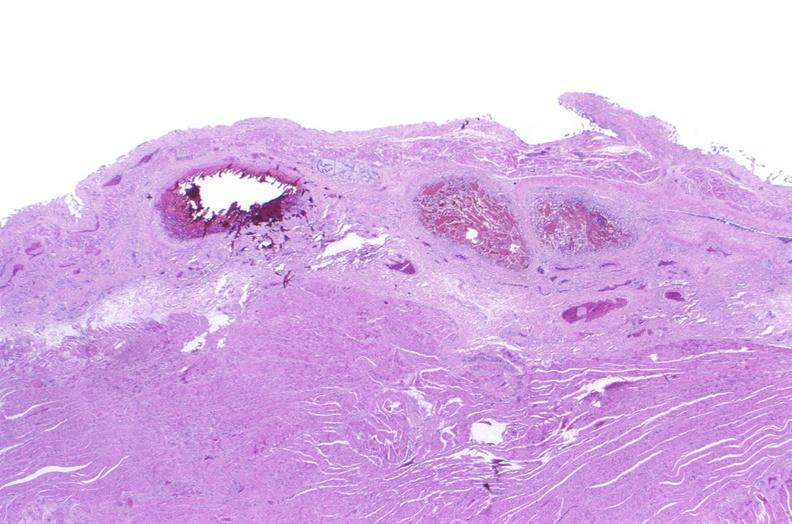what does this image show?
Answer the question using a single word or phrase. Esophagus 